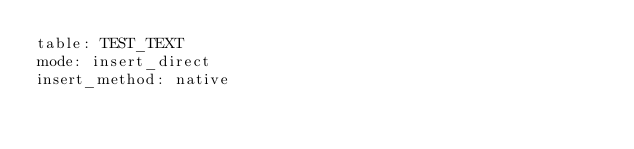Convert code to text. <code><loc_0><loc_0><loc_500><loc_500><_YAML_>table: TEST_TEXT
mode: insert_direct
insert_method: native
</code> 